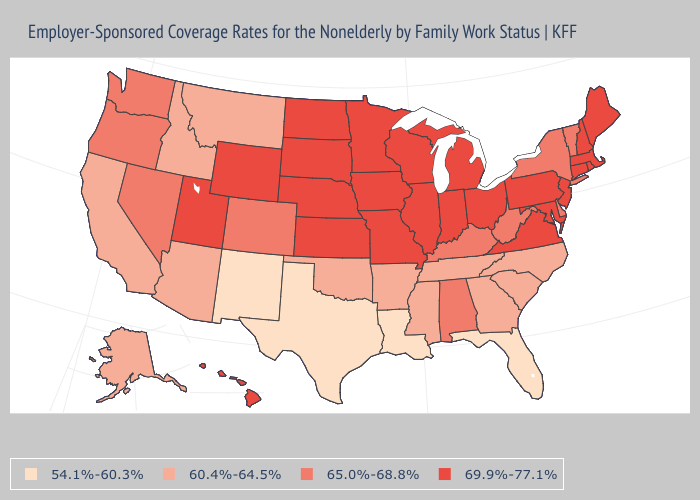What is the lowest value in states that border Missouri?
Give a very brief answer. 60.4%-64.5%. Does the map have missing data?
Concise answer only. No. What is the highest value in the MidWest ?
Concise answer only. 69.9%-77.1%. What is the value of Maine?
Concise answer only. 69.9%-77.1%. Name the states that have a value in the range 65.0%-68.8%?
Write a very short answer. Alabama, Colorado, Delaware, Kentucky, Nevada, New York, Oregon, Vermont, Washington, West Virginia. What is the lowest value in the USA?
Short answer required. 54.1%-60.3%. Does New Hampshire have a higher value than New York?
Short answer required. Yes. Name the states that have a value in the range 54.1%-60.3%?
Short answer required. Florida, Louisiana, New Mexico, Texas. What is the value of California?
Concise answer only. 60.4%-64.5%. Name the states that have a value in the range 60.4%-64.5%?
Give a very brief answer. Alaska, Arizona, Arkansas, California, Georgia, Idaho, Mississippi, Montana, North Carolina, Oklahoma, South Carolina, Tennessee. What is the value of Mississippi?
Short answer required. 60.4%-64.5%. What is the value of Virginia?
Answer briefly. 69.9%-77.1%. Which states hav the highest value in the West?
Concise answer only. Hawaii, Utah, Wyoming. Name the states that have a value in the range 69.9%-77.1%?
Concise answer only. Connecticut, Hawaii, Illinois, Indiana, Iowa, Kansas, Maine, Maryland, Massachusetts, Michigan, Minnesota, Missouri, Nebraska, New Hampshire, New Jersey, North Dakota, Ohio, Pennsylvania, Rhode Island, South Dakota, Utah, Virginia, Wisconsin, Wyoming. Does Virginia have the highest value in the South?
Short answer required. Yes. 